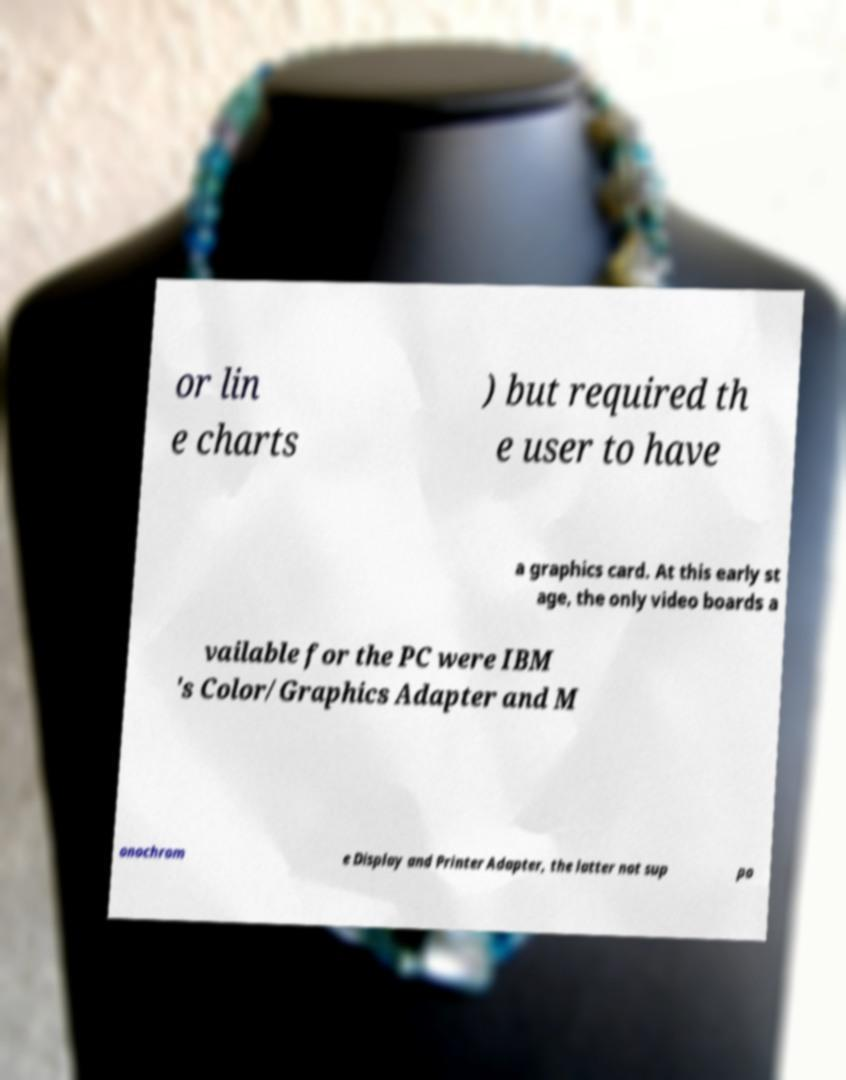For documentation purposes, I need the text within this image transcribed. Could you provide that? or lin e charts ) but required th e user to have a graphics card. At this early st age, the only video boards a vailable for the PC were IBM 's Color/Graphics Adapter and M onochrom e Display and Printer Adapter, the latter not sup po 